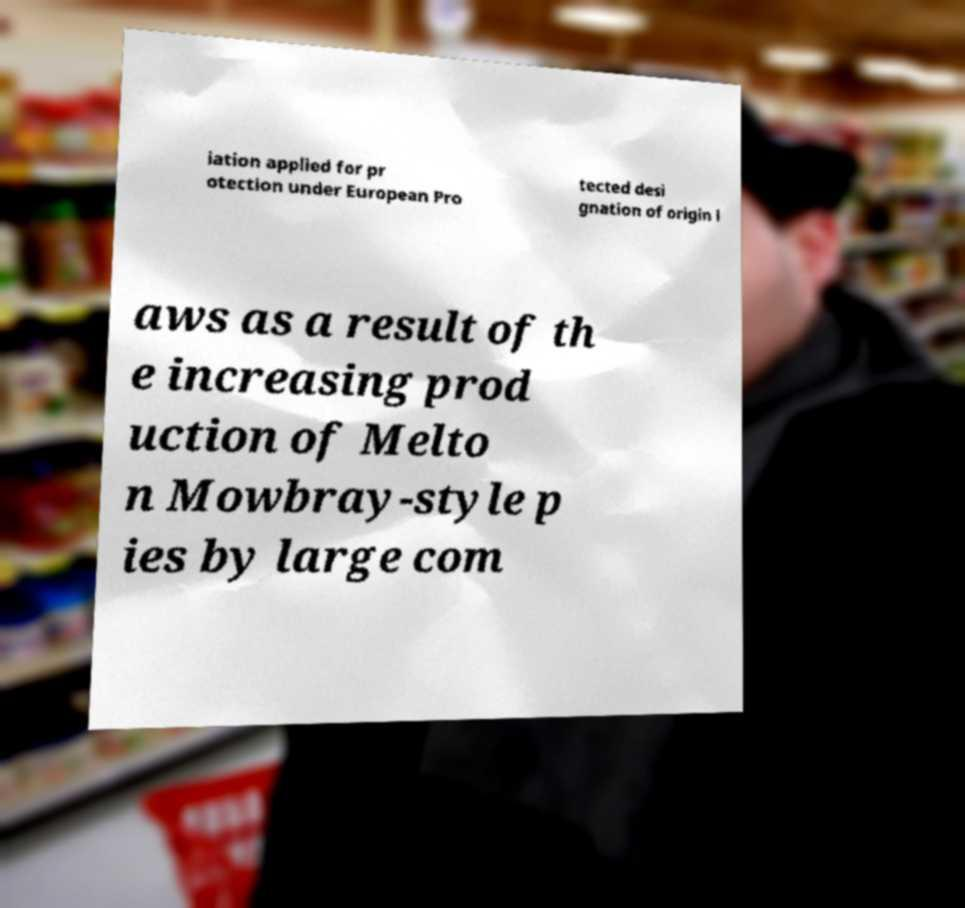Please identify and transcribe the text found in this image. iation applied for pr otection under European Pro tected desi gnation of origin l aws as a result of th e increasing prod uction of Melto n Mowbray-style p ies by large com 